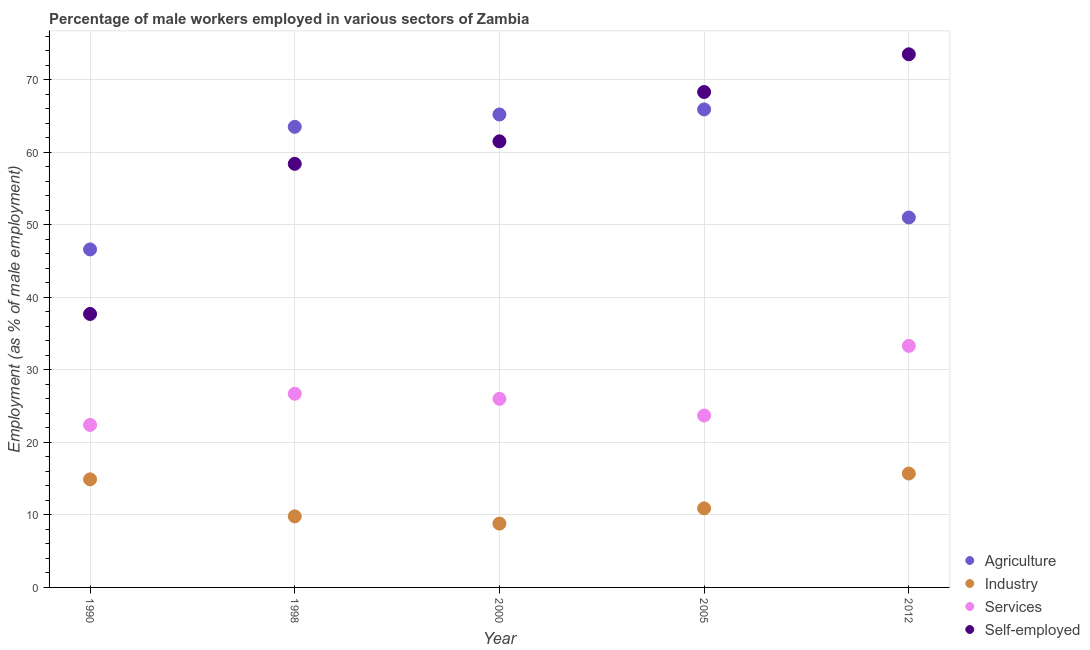What is the percentage of male workers in agriculture in 2000?
Provide a succinct answer. 65.2. Across all years, what is the maximum percentage of male workers in industry?
Keep it short and to the point. 15.7. Across all years, what is the minimum percentage of male workers in services?
Make the answer very short. 22.4. What is the total percentage of male workers in industry in the graph?
Your answer should be very brief. 60.1. What is the difference between the percentage of self employed male workers in 1998 and that in 2005?
Your answer should be very brief. -9.9. What is the difference between the percentage of self employed male workers in 2012 and the percentage of male workers in industry in 2005?
Offer a terse response. 62.6. What is the average percentage of male workers in industry per year?
Ensure brevity in your answer.  12.02. In the year 2012, what is the difference between the percentage of self employed male workers and percentage of male workers in industry?
Provide a short and direct response. 57.8. What is the ratio of the percentage of male workers in agriculture in 1998 to that in 2005?
Provide a succinct answer. 0.96. Is the difference between the percentage of male workers in industry in 1998 and 2012 greater than the difference between the percentage of male workers in services in 1998 and 2012?
Offer a very short reply. Yes. What is the difference between the highest and the second highest percentage of male workers in services?
Your response must be concise. 6.6. What is the difference between the highest and the lowest percentage of self employed male workers?
Your answer should be very brief. 35.8. In how many years, is the percentage of male workers in agriculture greater than the average percentage of male workers in agriculture taken over all years?
Offer a very short reply. 3. Is the sum of the percentage of male workers in services in 1990 and 1998 greater than the maximum percentage of male workers in industry across all years?
Your answer should be very brief. Yes. Is it the case that in every year, the sum of the percentage of self employed male workers and percentage of male workers in services is greater than the sum of percentage of male workers in agriculture and percentage of male workers in industry?
Your answer should be compact. Yes. Is the percentage of self employed male workers strictly greater than the percentage of male workers in industry over the years?
Give a very brief answer. Yes. Is the percentage of self employed male workers strictly less than the percentage of male workers in services over the years?
Your answer should be compact. No. Does the graph contain any zero values?
Give a very brief answer. No. Does the graph contain grids?
Your answer should be compact. Yes. Where does the legend appear in the graph?
Make the answer very short. Bottom right. How many legend labels are there?
Make the answer very short. 4. What is the title of the graph?
Provide a succinct answer. Percentage of male workers employed in various sectors of Zambia. What is the label or title of the X-axis?
Your response must be concise. Year. What is the label or title of the Y-axis?
Offer a very short reply. Employment (as % of male employment). What is the Employment (as % of male employment) of Agriculture in 1990?
Make the answer very short. 46.6. What is the Employment (as % of male employment) in Industry in 1990?
Offer a very short reply. 14.9. What is the Employment (as % of male employment) in Services in 1990?
Make the answer very short. 22.4. What is the Employment (as % of male employment) of Self-employed in 1990?
Keep it short and to the point. 37.7. What is the Employment (as % of male employment) of Agriculture in 1998?
Offer a very short reply. 63.5. What is the Employment (as % of male employment) in Industry in 1998?
Keep it short and to the point. 9.8. What is the Employment (as % of male employment) in Services in 1998?
Your answer should be compact. 26.7. What is the Employment (as % of male employment) in Self-employed in 1998?
Provide a short and direct response. 58.4. What is the Employment (as % of male employment) of Agriculture in 2000?
Make the answer very short. 65.2. What is the Employment (as % of male employment) in Industry in 2000?
Give a very brief answer. 8.8. What is the Employment (as % of male employment) of Services in 2000?
Make the answer very short. 26. What is the Employment (as % of male employment) of Self-employed in 2000?
Ensure brevity in your answer.  61.5. What is the Employment (as % of male employment) of Agriculture in 2005?
Give a very brief answer. 65.9. What is the Employment (as % of male employment) of Industry in 2005?
Your response must be concise. 10.9. What is the Employment (as % of male employment) of Services in 2005?
Ensure brevity in your answer.  23.7. What is the Employment (as % of male employment) in Self-employed in 2005?
Your response must be concise. 68.3. What is the Employment (as % of male employment) of Industry in 2012?
Keep it short and to the point. 15.7. What is the Employment (as % of male employment) in Services in 2012?
Your answer should be very brief. 33.3. What is the Employment (as % of male employment) of Self-employed in 2012?
Your answer should be compact. 73.5. Across all years, what is the maximum Employment (as % of male employment) of Agriculture?
Your answer should be compact. 65.9. Across all years, what is the maximum Employment (as % of male employment) in Industry?
Your answer should be compact. 15.7. Across all years, what is the maximum Employment (as % of male employment) of Services?
Your answer should be compact. 33.3. Across all years, what is the maximum Employment (as % of male employment) in Self-employed?
Your answer should be compact. 73.5. Across all years, what is the minimum Employment (as % of male employment) in Agriculture?
Provide a short and direct response. 46.6. Across all years, what is the minimum Employment (as % of male employment) of Industry?
Offer a very short reply. 8.8. Across all years, what is the minimum Employment (as % of male employment) in Services?
Provide a short and direct response. 22.4. Across all years, what is the minimum Employment (as % of male employment) in Self-employed?
Give a very brief answer. 37.7. What is the total Employment (as % of male employment) in Agriculture in the graph?
Ensure brevity in your answer.  292.2. What is the total Employment (as % of male employment) in Industry in the graph?
Give a very brief answer. 60.1. What is the total Employment (as % of male employment) in Services in the graph?
Keep it short and to the point. 132.1. What is the total Employment (as % of male employment) in Self-employed in the graph?
Offer a very short reply. 299.4. What is the difference between the Employment (as % of male employment) in Agriculture in 1990 and that in 1998?
Keep it short and to the point. -16.9. What is the difference between the Employment (as % of male employment) of Self-employed in 1990 and that in 1998?
Provide a succinct answer. -20.7. What is the difference between the Employment (as % of male employment) of Agriculture in 1990 and that in 2000?
Ensure brevity in your answer.  -18.6. What is the difference between the Employment (as % of male employment) of Industry in 1990 and that in 2000?
Provide a succinct answer. 6.1. What is the difference between the Employment (as % of male employment) of Self-employed in 1990 and that in 2000?
Your answer should be compact. -23.8. What is the difference between the Employment (as % of male employment) in Agriculture in 1990 and that in 2005?
Make the answer very short. -19.3. What is the difference between the Employment (as % of male employment) in Services in 1990 and that in 2005?
Keep it short and to the point. -1.3. What is the difference between the Employment (as % of male employment) of Self-employed in 1990 and that in 2005?
Provide a succinct answer. -30.6. What is the difference between the Employment (as % of male employment) of Agriculture in 1990 and that in 2012?
Provide a succinct answer. -4.4. What is the difference between the Employment (as % of male employment) in Self-employed in 1990 and that in 2012?
Your answer should be compact. -35.8. What is the difference between the Employment (as % of male employment) of Agriculture in 1998 and that in 2000?
Ensure brevity in your answer.  -1.7. What is the difference between the Employment (as % of male employment) of Industry in 1998 and that in 2000?
Your answer should be compact. 1. What is the difference between the Employment (as % of male employment) of Services in 1998 and that in 2000?
Your response must be concise. 0.7. What is the difference between the Employment (as % of male employment) of Self-employed in 1998 and that in 2000?
Your response must be concise. -3.1. What is the difference between the Employment (as % of male employment) of Self-employed in 1998 and that in 2005?
Your answer should be very brief. -9.9. What is the difference between the Employment (as % of male employment) of Agriculture in 1998 and that in 2012?
Ensure brevity in your answer.  12.5. What is the difference between the Employment (as % of male employment) in Industry in 1998 and that in 2012?
Ensure brevity in your answer.  -5.9. What is the difference between the Employment (as % of male employment) in Services in 1998 and that in 2012?
Give a very brief answer. -6.6. What is the difference between the Employment (as % of male employment) of Self-employed in 1998 and that in 2012?
Make the answer very short. -15.1. What is the difference between the Employment (as % of male employment) of Agriculture in 2000 and that in 2005?
Your answer should be very brief. -0.7. What is the difference between the Employment (as % of male employment) of Industry in 2000 and that in 2005?
Offer a terse response. -2.1. What is the difference between the Employment (as % of male employment) in Agriculture in 2000 and that in 2012?
Keep it short and to the point. 14.2. What is the difference between the Employment (as % of male employment) of Industry in 2000 and that in 2012?
Make the answer very short. -6.9. What is the difference between the Employment (as % of male employment) in Services in 2000 and that in 2012?
Ensure brevity in your answer.  -7.3. What is the difference between the Employment (as % of male employment) of Self-employed in 2000 and that in 2012?
Make the answer very short. -12. What is the difference between the Employment (as % of male employment) in Industry in 2005 and that in 2012?
Offer a very short reply. -4.8. What is the difference between the Employment (as % of male employment) in Agriculture in 1990 and the Employment (as % of male employment) in Industry in 1998?
Offer a very short reply. 36.8. What is the difference between the Employment (as % of male employment) in Agriculture in 1990 and the Employment (as % of male employment) in Self-employed in 1998?
Your response must be concise. -11.8. What is the difference between the Employment (as % of male employment) in Industry in 1990 and the Employment (as % of male employment) in Services in 1998?
Make the answer very short. -11.8. What is the difference between the Employment (as % of male employment) in Industry in 1990 and the Employment (as % of male employment) in Self-employed in 1998?
Provide a short and direct response. -43.5. What is the difference between the Employment (as % of male employment) of Services in 1990 and the Employment (as % of male employment) of Self-employed in 1998?
Offer a very short reply. -36. What is the difference between the Employment (as % of male employment) in Agriculture in 1990 and the Employment (as % of male employment) in Industry in 2000?
Offer a very short reply. 37.8. What is the difference between the Employment (as % of male employment) in Agriculture in 1990 and the Employment (as % of male employment) in Services in 2000?
Ensure brevity in your answer.  20.6. What is the difference between the Employment (as % of male employment) in Agriculture in 1990 and the Employment (as % of male employment) in Self-employed in 2000?
Offer a terse response. -14.9. What is the difference between the Employment (as % of male employment) in Industry in 1990 and the Employment (as % of male employment) in Services in 2000?
Ensure brevity in your answer.  -11.1. What is the difference between the Employment (as % of male employment) in Industry in 1990 and the Employment (as % of male employment) in Self-employed in 2000?
Make the answer very short. -46.6. What is the difference between the Employment (as % of male employment) in Services in 1990 and the Employment (as % of male employment) in Self-employed in 2000?
Make the answer very short. -39.1. What is the difference between the Employment (as % of male employment) in Agriculture in 1990 and the Employment (as % of male employment) in Industry in 2005?
Your answer should be very brief. 35.7. What is the difference between the Employment (as % of male employment) of Agriculture in 1990 and the Employment (as % of male employment) of Services in 2005?
Give a very brief answer. 22.9. What is the difference between the Employment (as % of male employment) of Agriculture in 1990 and the Employment (as % of male employment) of Self-employed in 2005?
Provide a succinct answer. -21.7. What is the difference between the Employment (as % of male employment) in Industry in 1990 and the Employment (as % of male employment) in Services in 2005?
Your answer should be very brief. -8.8. What is the difference between the Employment (as % of male employment) in Industry in 1990 and the Employment (as % of male employment) in Self-employed in 2005?
Your answer should be compact. -53.4. What is the difference between the Employment (as % of male employment) in Services in 1990 and the Employment (as % of male employment) in Self-employed in 2005?
Your answer should be very brief. -45.9. What is the difference between the Employment (as % of male employment) in Agriculture in 1990 and the Employment (as % of male employment) in Industry in 2012?
Make the answer very short. 30.9. What is the difference between the Employment (as % of male employment) of Agriculture in 1990 and the Employment (as % of male employment) of Self-employed in 2012?
Provide a short and direct response. -26.9. What is the difference between the Employment (as % of male employment) of Industry in 1990 and the Employment (as % of male employment) of Services in 2012?
Provide a succinct answer. -18.4. What is the difference between the Employment (as % of male employment) of Industry in 1990 and the Employment (as % of male employment) of Self-employed in 2012?
Provide a succinct answer. -58.6. What is the difference between the Employment (as % of male employment) of Services in 1990 and the Employment (as % of male employment) of Self-employed in 2012?
Your answer should be compact. -51.1. What is the difference between the Employment (as % of male employment) of Agriculture in 1998 and the Employment (as % of male employment) of Industry in 2000?
Ensure brevity in your answer.  54.7. What is the difference between the Employment (as % of male employment) in Agriculture in 1998 and the Employment (as % of male employment) in Services in 2000?
Provide a succinct answer. 37.5. What is the difference between the Employment (as % of male employment) of Agriculture in 1998 and the Employment (as % of male employment) of Self-employed in 2000?
Make the answer very short. 2. What is the difference between the Employment (as % of male employment) in Industry in 1998 and the Employment (as % of male employment) in Services in 2000?
Your answer should be very brief. -16.2. What is the difference between the Employment (as % of male employment) in Industry in 1998 and the Employment (as % of male employment) in Self-employed in 2000?
Keep it short and to the point. -51.7. What is the difference between the Employment (as % of male employment) of Services in 1998 and the Employment (as % of male employment) of Self-employed in 2000?
Offer a very short reply. -34.8. What is the difference between the Employment (as % of male employment) in Agriculture in 1998 and the Employment (as % of male employment) in Industry in 2005?
Your response must be concise. 52.6. What is the difference between the Employment (as % of male employment) in Agriculture in 1998 and the Employment (as % of male employment) in Services in 2005?
Make the answer very short. 39.8. What is the difference between the Employment (as % of male employment) of Agriculture in 1998 and the Employment (as % of male employment) of Self-employed in 2005?
Give a very brief answer. -4.8. What is the difference between the Employment (as % of male employment) of Industry in 1998 and the Employment (as % of male employment) of Services in 2005?
Your answer should be compact. -13.9. What is the difference between the Employment (as % of male employment) in Industry in 1998 and the Employment (as % of male employment) in Self-employed in 2005?
Your answer should be very brief. -58.5. What is the difference between the Employment (as % of male employment) in Services in 1998 and the Employment (as % of male employment) in Self-employed in 2005?
Provide a succinct answer. -41.6. What is the difference between the Employment (as % of male employment) of Agriculture in 1998 and the Employment (as % of male employment) of Industry in 2012?
Ensure brevity in your answer.  47.8. What is the difference between the Employment (as % of male employment) of Agriculture in 1998 and the Employment (as % of male employment) of Services in 2012?
Offer a terse response. 30.2. What is the difference between the Employment (as % of male employment) of Industry in 1998 and the Employment (as % of male employment) of Services in 2012?
Provide a short and direct response. -23.5. What is the difference between the Employment (as % of male employment) of Industry in 1998 and the Employment (as % of male employment) of Self-employed in 2012?
Ensure brevity in your answer.  -63.7. What is the difference between the Employment (as % of male employment) in Services in 1998 and the Employment (as % of male employment) in Self-employed in 2012?
Offer a terse response. -46.8. What is the difference between the Employment (as % of male employment) in Agriculture in 2000 and the Employment (as % of male employment) in Industry in 2005?
Give a very brief answer. 54.3. What is the difference between the Employment (as % of male employment) in Agriculture in 2000 and the Employment (as % of male employment) in Services in 2005?
Keep it short and to the point. 41.5. What is the difference between the Employment (as % of male employment) of Agriculture in 2000 and the Employment (as % of male employment) of Self-employed in 2005?
Your response must be concise. -3.1. What is the difference between the Employment (as % of male employment) of Industry in 2000 and the Employment (as % of male employment) of Services in 2005?
Your answer should be very brief. -14.9. What is the difference between the Employment (as % of male employment) of Industry in 2000 and the Employment (as % of male employment) of Self-employed in 2005?
Your answer should be compact. -59.5. What is the difference between the Employment (as % of male employment) of Services in 2000 and the Employment (as % of male employment) of Self-employed in 2005?
Provide a succinct answer. -42.3. What is the difference between the Employment (as % of male employment) of Agriculture in 2000 and the Employment (as % of male employment) of Industry in 2012?
Provide a short and direct response. 49.5. What is the difference between the Employment (as % of male employment) in Agriculture in 2000 and the Employment (as % of male employment) in Services in 2012?
Provide a short and direct response. 31.9. What is the difference between the Employment (as % of male employment) of Agriculture in 2000 and the Employment (as % of male employment) of Self-employed in 2012?
Give a very brief answer. -8.3. What is the difference between the Employment (as % of male employment) in Industry in 2000 and the Employment (as % of male employment) in Services in 2012?
Offer a terse response. -24.5. What is the difference between the Employment (as % of male employment) in Industry in 2000 and the Employment (as % of male employment) in Self-employed in 2012?
Give a very brief answer. -64.7. What is the difference between the Employment (as % of male employment) of Services in 2000 and the Employment (as % of male employment) of Self-employed in 2012?
Your answer should be compact. -47.5. What is the difference between the Employment (as % of male employment) of Agriculture in 2005 and the Employment (as % of male employment) of Industry in 2012?
Keep it short and to the point. 50.2. What is the difference between the Employment (as % of male employment) of Agriculture in 2005 and the Employment (as % of male employment) of Services in 2012?
Provide a short and direct response. 32.6. What is the difference between the Employment (as % of male employment) in Industry in 2005 and the Employment (as % of male employment) in Services in 2012?
Your response must be concise. -22.4. What is the difference between the Employment (as % of male employment) in Industry in 2005 and the Employment (as % of male employment) in Self-employed in 2012?
Ensure brevity in your answer.  -62.6. What is the difference between the Employment (as % of male employment) of Services in 2005 and the Employment (as % of male employment) of Self-employed in 2012?
Your answer should be very brief. -49.8. What is the average Employment (as % of male employment) of Agriculture per year?
Offer a terse response. 58.44. What is the average Employment (as % of male employment) of Industry per year?
Offer a very short reply. 12.02. What is the average Employment (as % of male employment) in Services per year?
Offer a terse response. 26.42. What is the average Employment (as % of male employment) of Self-employed per year?
Your answer should be very brief. 59.88. In the year 1990, what is the difference between the Employment (as % of male employment) in Agriculture and Employment (as % of male employment) in Industry?
Provide a short and direct response. 31.7. In the year 1990, what is the difference between the Employment (as % of male employment) in Agriculture and Employment (as % of male employment) in Services?
Offer a terse response. 24.2. In the year 1990, what is the difference between the Employment (as % of male employment) of Industry and Employment (as % of male employment) of Self-employed?
Ensure brevity in your answer.  -22.8. In the year 1990, what is the difference between the Employment (as % of male employment) of Services and Employment (as % of male employment) of Self-employed?
Your answer should be very brief. -15.3. In the year 1998, what is the difference between the Employment (as % of male employment) of Agriculture and Employment (as % of male employment) of Industry?
Ensure brevity in your answer.  53.7. In the year 1998, what is the difference between the Employment (as % of male employment) in Agriculture and Employment (as % of male employment) in Services?
Give a very brief answer. 36.8. In the year 1998, what is the difference between the Employment (as % of male employment) of Agriculture and Employment (as % of male employment) of Self-employed?
Provide a succinct answer. 5.1. In the year 1998, what is the difference between the Employment (as % of male employment) in Industry and Employment (as % of male employment) in Services?
Your response must be concise. -16.9. In the year 1998, what is the difference between the Employment (as % of male employment) of Industry and Employment (as % of male employment) of Self-employed?
Provide a succinct answer. -48.6. In the year 1998, what is the difference between the Employment (as % of male employment) in Services and Employment (as % of male employment) in Self-employed?
Keep it short and to the point. -31.7. In the year 2000, what is the difference between the Employment (as % of male employment) in Agriculture and Employment (as % of male employment) in Industry?
Ensure brevity in your answer.  56.4. In the year 2000, what is the difference between the Employment (as % of male employment) in Agriculture and Employment (as % of male employment) in Services?
Provide a short and direct response. 39.2. In the year 2000, what is the difference between the Employment (as % of male employment) of Industry and Employment (as % of male employment) of Services?
Keep it short and to the point. -17.2. In the year 2000, what is the difference between the Employment (as % of male employment) in Industry and Employment (as % of male employment) in Self-employed?
Ensure brevity in your answer.  -52.7. In the year 2000, what is the difference between the Employment (as % of male employment) of Services and Employment (as % of male employment) of Self-employed?
Your answer should be very brief. -35.5. In the year 2005, what is the difference between the Employment (as % of male employment) of Agriculture and Employment (as % of male employment) of Industry?
Your answer should be compact. 55. In the year 2005, what is the difference between the Employment (as % of male employment) of Agriculture and Employment (as % of male employment) of Services?
Make the answer very short. 42.2. In the year 2005, what is the difference between the Employment (as % of male employment) of Industry and Employment (as % of male employment) of Self-employed?
Provide a succinct answer. -57.4. In the year 2005, what is the difference between the Employment (as % of male employment) in Services and Employment (as % of male employment) in Self-employed?
Give a very brief answer. -44.6. In the year 2012, what is the difference between the Employment (as % of male employment) of Agriculture and Employment (as % of male employment) of Industry?
Your answer should be compact. 35.3. In the year 2012, what is the difference between the Employment (as % of male employment) in Agriculture and Employment (as % of male employment) in Services?
Provide a short and direct response. 17.7. In the year 2012, what is the difference between the Employment (as % of male employment) of Agriculture and Employment (as % of male employment) of Self-employed?
Offer a terse response. -22.5. In the year 2012, what is the difference between the Employment (as % of male employment) of Industry and Employment (as % of male employment) of Services?
Give a very brief answer. -17.6. In the year 2012, what is the difference between the Employment (as % of male employment) of Industry and Employment (as % of male employment) of Self-employed?
Ensure brevity in your answer.  -57.8. In the year 2012, what is the difference between the Employment (as % of male employment) of Services and Employment (as % of male employment) of Self-employed?
Make the answer very short. -40.2. What is the ratio of the Employment (as % of male employment) in Agriculture in 1990 to that in 1998?
Offer a very short reply. 0.73. What is the ratio of the Employment (as % of male employment) in Industry in 1990 to that in 1998?
Your answer should be compact. 1.52. What is the ratio of the Employment (as % of male employment) of Services in 1990 to that in 1998?
Offer a very short reply. 0.84. What is the ratio of the Employment (as % of male employment) in Self-employed in 1990 to that in 1998?
Provide a succinct answer. 0.65. What is the ratio of the Employment (as % of male employment) of Agriculture in 1990 to that in 2000?
Your response must be concise. 0.71. What is the ratio of the Employment (as % of male employment) of Industry in 1990 to that in 2000?
Make the answer very short. 1.69. What is the ratio of the Employment (as % of male employment) in Services in 1990 to that in 2000?
Make the answer very short. 0.86. What is the ratio of the Employment (as % of male employment) of Self-employed in 1990 to that in 2000?
Make the answer very short. 0.61. What is the ratio of the Employment (as % of male employment) of Agriculture in 1990 to that in 2005?
Your response must be concise. 0.71. What is the ratio of the Employment (as % of male employment) of Industry in 1990 to that in 2005?
Offer a terse response. 1.37. What is the ratio of the Employment (as % of male employment) in Services in 1990 to that in 2005?
Offer a terse response. 0.95. What is the ratio of the Employment (as % of male employment) in Self-employed in 1990 to that in 2005?
Provide a succinct answer. 0.55. What is the ratio of the Employment (as % of male employment) in Agriculture in 1990 to that in 2012?
Your answer should be compact. 0.91. What is the ratio of the Employment (as % of male employment) of Industry in 1990 to that in 2012?
Ensure brevity in your answer.  0.95. What is the ratio of the Employment (as % of male employment) of Services in 1990 to that in 2012?
Provide a succinct answer. 0.67. What is the ratio of the Employment (as % of male employment) in Self-employed in 1990 to that in 2012?
Your response must be concise. 0.51. What is the ratio of the Employment (as % of male employment) of Agriculture in 1998 to that in 2000?
Make the answer very short. 0.97. What is the ratio of the Employment (as % of male employment) of Industry in 1998 to that in 2000?
Keep it short and to the point. 1.11. What is the ratio of the Employment (as % of male employment) of Services in 1998 to that in 2000?
Provide a short and direct response. 1.03. What is the ratio of the Employment (as % of male employment) of Self-employed in 1998 to that in 2000?
Your answer should be very brief. 0.95. What is the ratio of the Employment (as % of male employment) in Agriculture in 1998 to that in 2005?
Give a very brief answer. 0.96. What is the ratio of the Employment (as % of male employment) in Industry in 1998 to that in 2005?
Make the answer very short. 0.9. What is the ratio of the Employment (as % of male employment) in Services in 1998 to that in 2005?
Offer a very short reply. 1.13. What is the ratio of the Employment (as % of male employment) in Self-employed in 1998 to that in 2005?
Provide a short and direct response. 0.86. What is the ratio of the Employment (as % of male employment) in Agriculture in 1998 to that in 2012?
Ensure brevity in your answer.  1.25. What is the ratio of the Employment (as % of male employment) in Industry in 1998 to that in 2012?
Ensure brevity in your answer.  0.62. What is the ratio of the Employment (as % of male employment) of Services in 1998 to that in 2012?
Make the answer very short. 0.8. What is the ratio of the Employment (as % of male employment) of Self-employed in 1998 to that in 2012?
Make the answer very short. 0.79. What is the ratio of the Employment (as % of male employment) of Industry in 2000 to that in 2005?
Give a very brief answer. 0.81. What is the ratio of the Employment (as % of male employment) in Services in 2000 to that in 2005?
Your answer should be very brief. 1.1. What is the ratio of the Employment (as % of male employment) of Self-employed in 2000 to that in 2005?
Your answer should be compact. 0.9. What is the ratio of the Employment (as % of male employment) of Agriculture in 2000 to that in 2012?
Give a very brief answer. 1.28. What is the ratio of the Employment (as % of male employment) of Industry in 2000 to that in 2012?
Provide a short and direct response. 0.56. What is the ratio of the Employment (as % of male employment) of Services in 2000 to that in 2012?
Your answer should be compact. 0.78. What is the ratio of the Employment (as % of male employment) of Self-employed in 2000 to that in 2012?
Make the answer very short. 0.84. What is the ratio of the Employment (as % of male employment) of Agriculture in 2005 to that in 2012?
Offer a very short reply. 1.29. What is the ratio of the Employment (as % of male employment) in Industry in 2005 to that in 2012?
Offer a very short reply. 0.69. What is the ratio of the Employment (as % of male employment) of Services in 2005 to that in 2012?
Give a very brief answer. 0.71. What is the ratio of the Employment (as % of male employment) of Self-employed in 2005 to that in 2012?
Ensure brevity in your answer.  0.93. What is the difference between the highest and the second highest Employment (as % of male employment) of Self-employed?
Provide a succinct answer. 5.2. What is the difference between the highest and the lowest Employment (as % of male employment) of Agriculture?
Keep it short and to the point. 19.3. What is the difference between the highest and the lowest Employment (as % of male employment) in Industry?
Your answer should be very brief. 6.9. What is the difference between the highest and the lowest Employment (as % of male employment) in Services?
Offer a terse response. 10.9. What is the difference between the highest and the lowest Employment (as % of male employment) of Self-employed?
Your answer should be very brief. 35.8. 